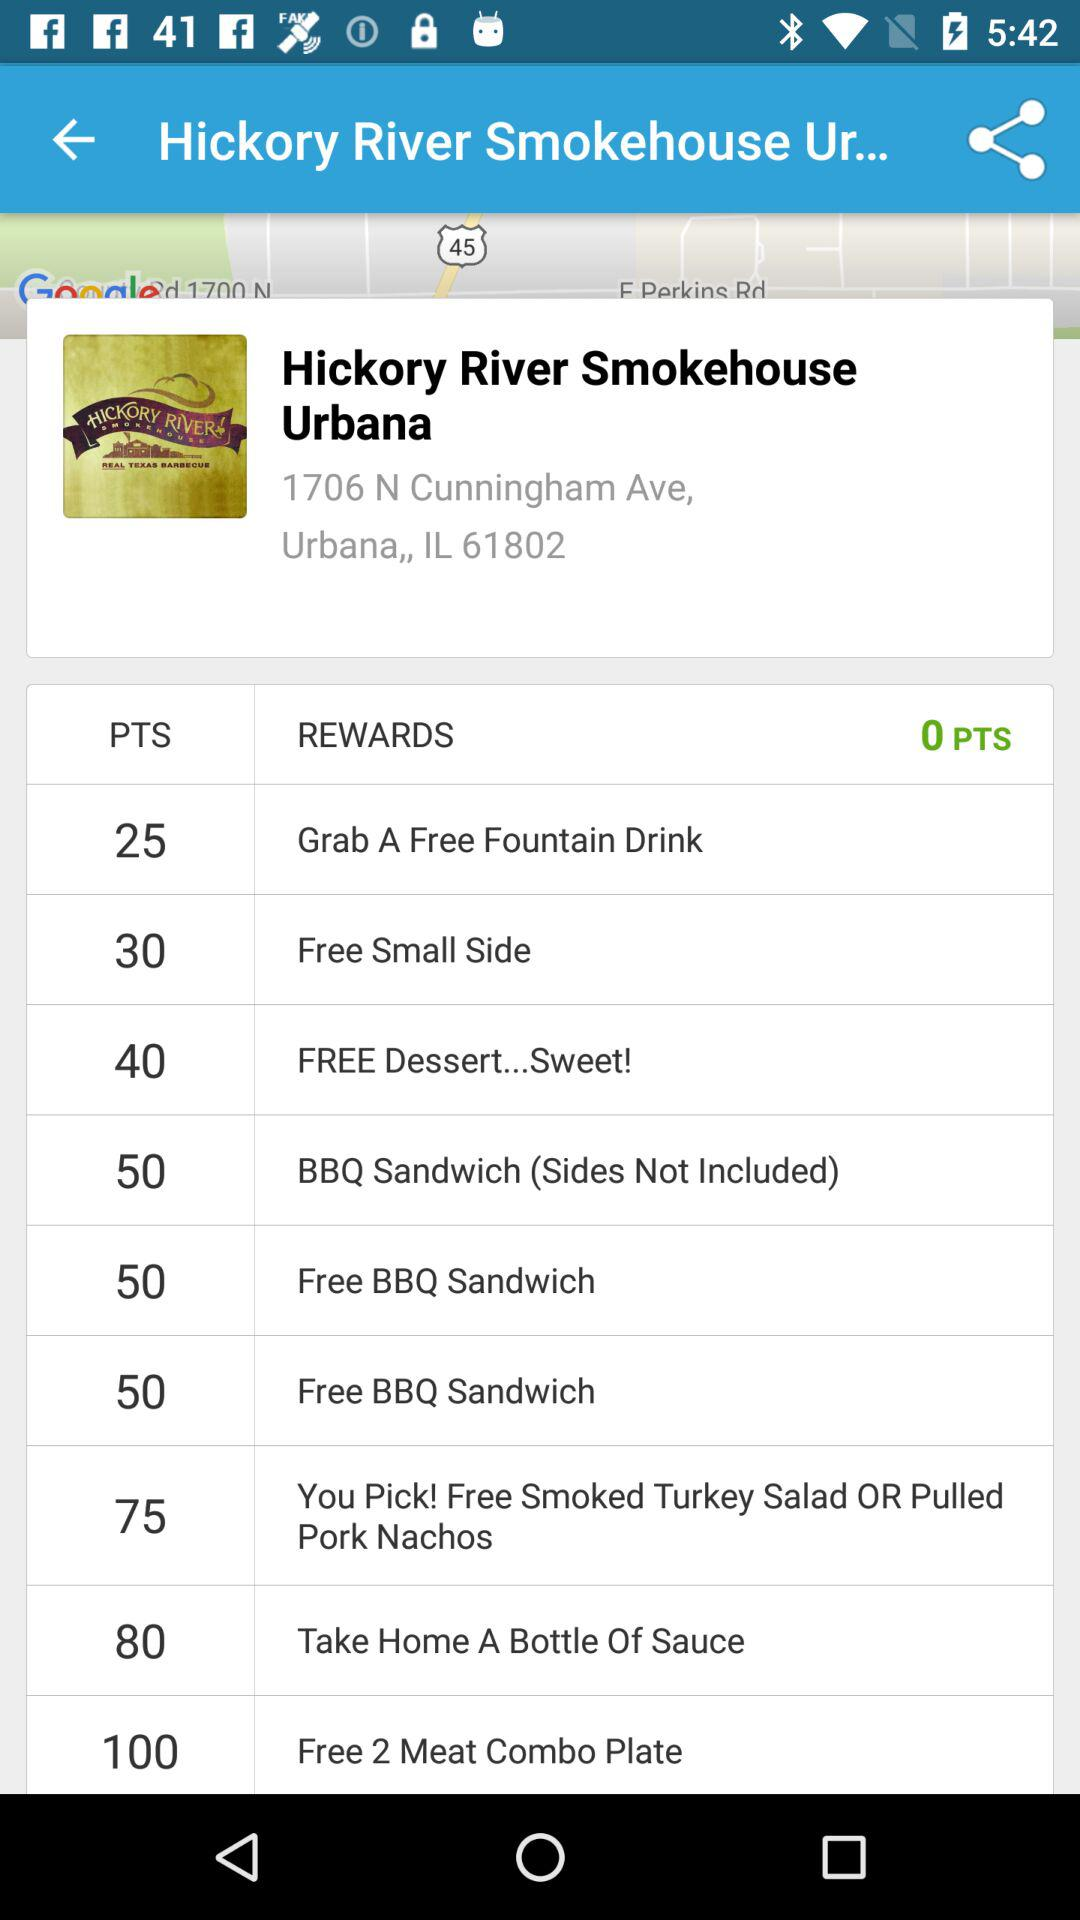How many points do I need to get a free 2 meat combo plate?
Answer the question using a single word or phrase. 100 